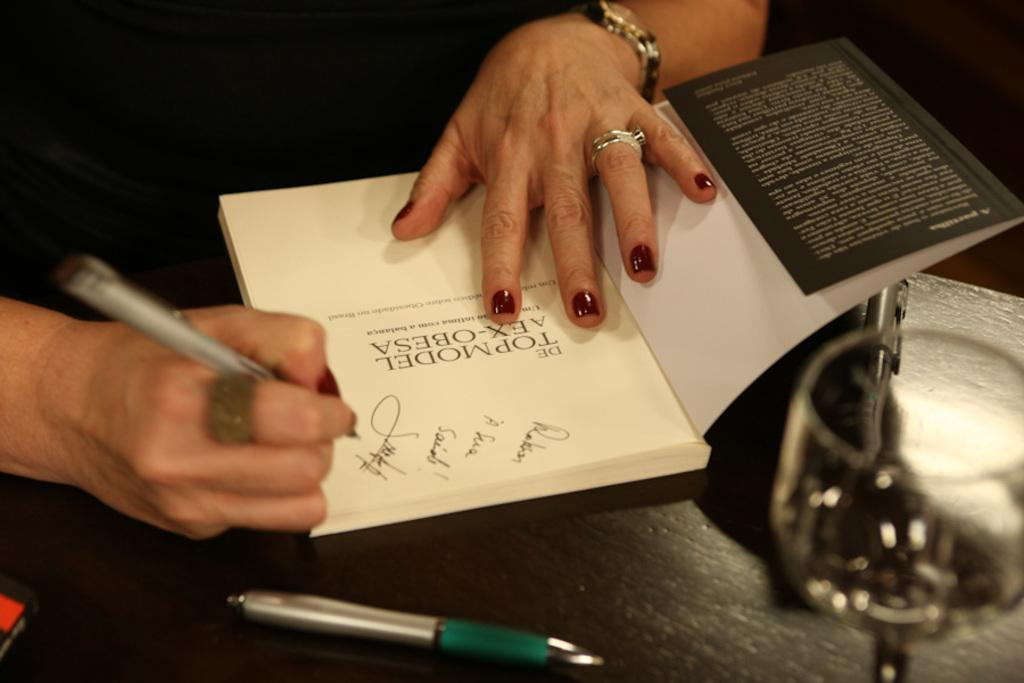Who is the person in the image? The person in the image is not specified, but we can see that they are writing in a book. What is the person using to write in the book? The person is using a pen to write in the book. Where is the book located? The book is on a table. What else can be found on the table? There are pens and a glass on the table. What is the value of the fog in the image? There is no fog present in the image, so it is not possible to determine its value. 